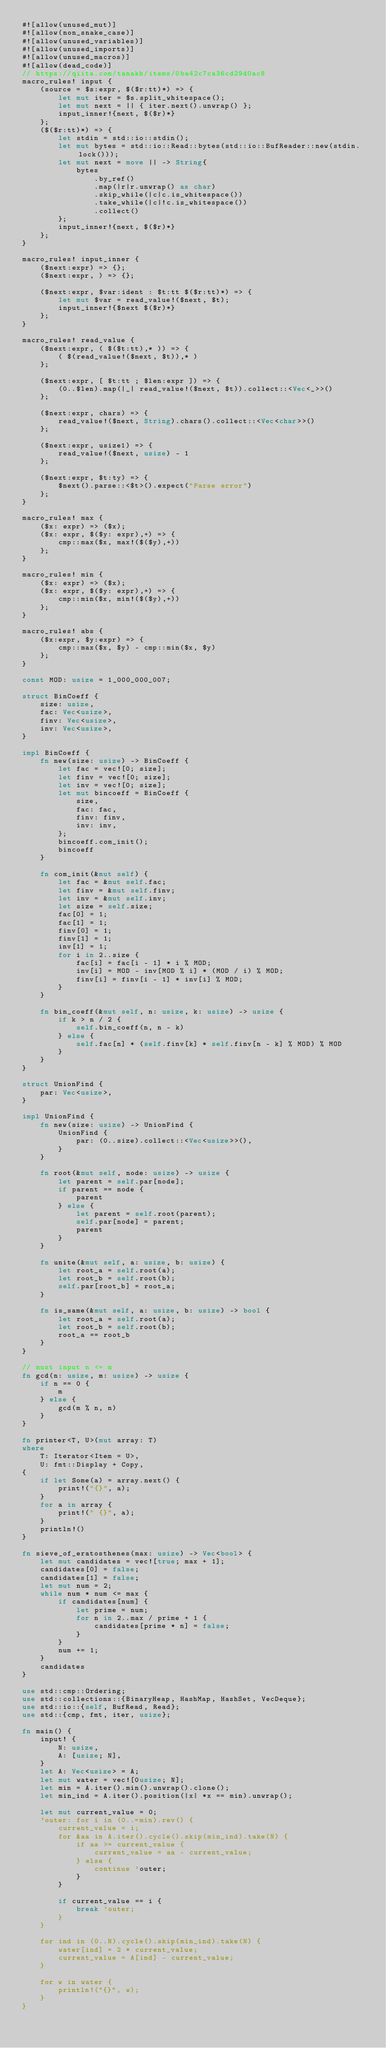<code> <loc_0><loc_0><loc_500><loc_500><_Rust_>#![allow(unused_mut)]
#![allow(non_snake_case)]
#![allow(unused_variables)]
#![allow(unused_imports)]
#![allow(unused_macros)]
#![allow(dead_code)]
// https://qiita.com/tanakh/items/0ba42c7ca36cd29d0ac8
macro_rules! input {
    (source = $s:expr, $($r:tt)*) => {
        let mut iter = $s.split_whitespace();
        let mut next = || { iter.next().unwrap() };
        input_inner!{next, $($r)*}
    };
    ($($r:tt)*) => {
        let stdin = std::io::stdin();
        let mut bytes = std::io::Read::bytes(std::io::BufReader::new(stdin.lock()));
        let mut next = move || -> String{
            bytes
                .by_ref()
                .map(|r|r.unwrap() as char)
                .skip_while(|c|c.is_whitespace())
                .take_while(|c|!c.is_whitespace())
                .collect()
        };
        input_inner!{next, $($r)*}
    };
}

macro_rules! input_inner {
    ($next:expr) => {};
    ($next:expr, ) => {};

    ($next:expr, $var:ident : $t:tt $($r:tt)*) => {
        let mut $var = read_value!($next, $t);
        input_inner!{$next $($r)*}
    };
}

macro_rules! read_value {
    ($next:expr, ( $($t:tt),* )) => {
        ( $(read_value!($next, $t)),* )
    };

    ($next:expr, [ $t:tt ; $len:expr ]) => {
        (0..$len).map(|_| read_value!($next, $t)).collect::<Vec<_>>()
    };

    ($next:expr, chars) => {
        read_value!($next, String).chars().collect::<Vec<char>>()
    };

    ($next:expr, usize1) => {
        read_value!($next, usize) - 1
    };

    ($next:expr, $t:ty) => {
        $next().parse::<$t>().expect("Parse error")
    };
}

macro_rules! max {
    ($x: expr) => ($x);
    ($x: expr, $($y: expr),+) => {
        cmp::max($x, max!($($y),+))
    };
}

macro_rules! min {
    ($x: expr) => ($x);
    ($x: expr, $($y: expr),+) => {
        cmp::min($x, min!($($y),+))
    };
}

macro_rules! abs {
    ($x:expr, $y:expr) => {
        cmp::max($x, $y) - cmp::min($x, $y)
    };
}

const MOD: usize = 1_000_000_007;

struct BinCoeff {
    size: usize,
    fac: Vec<usize>,
    finv: Vec<usize>,
    inv: Vec<usize>,
}

impl BinCoeff {
    fn new(size: usize) -> BinCoeff {
        let fac = vec![0; size];
        let finv = vec![0; size];
        let inv = vec![0; size];
        let mut bincoeff = BinCoeff {
            size,
            fac: fac,
            finv: finv,
            inv: inv,
        };
        bincoeff.com_init();
        bincoeff
    }

    fn com_init(&mut self) {
        let fac = &mut self.fac;
        let finv = &mut self.finv;
        let inv = &mut self.inv;
        let size = self.size;
        fac[0] = 1;
        fac[1] = 1;
        finv[0] = 1;
        finv[1] = 1;
        inv[1] = 1;
        for i in 2..size {
            fac[i] = fac[i - 1] * i % MOD;
            inv[i] = MOD - inv[MOD % i] * (MOD / i) % MOD;
            finv[i] = finv[i - 1] * inv[i] % MOD;
        }
    }

    fn bin_coeff(&mut self, n: usize, k: usize) -> usize {
        if k > n / 2 {
            self.bin_coeff(n, n - k)
        } else {
            self.fac[n] * (self.finv[k] * self.finv[n - k] % MOD) % MOD
        }
    }
}

struct UnionFind {
    par: Vec<usize>,
}

impl UnionFind {
    fn new(size: usize) -> UnionFind {
        UnionFind {
            par: (0..size).collect::<Vec<usize>>(),
        }
    }

    fn root(&mut self, node: usize) -> usize {
        let parent = self.par[node];
        if parent == node {
            parent
        } else {
            let parent = self.root(parent);
            self.par[node] = parent;
            parent
        }
    }

    fn unite(&mut self, a: usize, b: usize) {
        let root_a = self.root(a);
        let root_b = self.root(b);
        self.par[root_b] = root_a;
    }

    fn is_same(&mut self, a: usize, b: usize) -> bool {
        let root_a = self.root(a);
        let root_b = self.root(b);
        root_a == root_b
    }
}

// must input n <= m
fn gcd(n: usize, m: usize) -> usize {
    if n == 0 {
        m
    } else {
        gcd(m % n, n)
    }
}

fn printer<T, U>(mut array: T)
where
    T: Iterator<Item = U>,
    U: fmt::Display + Copy,
{
    if let Some(a) = array.next() {
        print!("{}", a);
    }
    for a in array {
        print!(" {}", a);
    }
    println!()
}

fn sieve_of_eratosthenes(max: usize) -> Vec<bool> {
    let mut candidates = vec![true; max + 1];
    candidates[0] = false;
    candidates[1] = false;
    let mut num = 2;
    while num * num <= max {
        if candidates[num] {
            let prime = num;
            for n in 2..max / prime + 1 {
                candidates[prime * n] = false;
            }
        }
        num += 1;
    }
    candidates
}

use std::cmp::Ordering;
use std::collections::{BinaryHeap, HashMap, HashSet, VecDeque};
use std::io::{self, BufRead, Read};
use std::{cmp, fmt, iter, usize};

fn main() {
    input! {
        N: usize,
        A: [usize; N],
    }
    let A: Vec<usize> = A;
    let mut water = vec![0usize; N];
    let min = A.iter().min().unwrap().clone();
    let min_ind = A.iter().position(|x| *x == min).unwrap();

    let mut current_value = 0;
    'outer: for i in (0..=min).rev() {
        current_value = i;
        for &aa in A.iter().cycle().skip(min_ind).take(N) {
            if aa >= current_value {
                current_value = aa - current_value;
            } else {
                continue 'outer;
            }
        }

        if current_value == i {
            break 'outer;
        }
    }

    for ind in (0..N).cycle().skip(min_ind).take(N) {
        water[ind] = 2 * current_value;
        current_value = A[ind] - current_value;
    }

    for w in water {
        println!("{}", w);
    }
}
</code> 